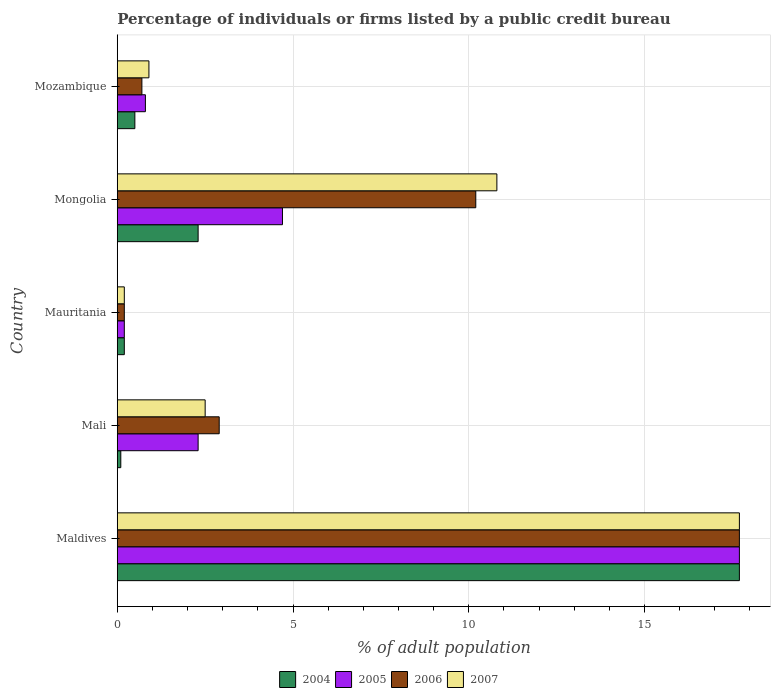How many different coloured bars are there?
Your answer should be compact. 4. How many bars are there on the 1st tick from the bottom?
Provide a short and direct response. 4. What is the label of the 4th group of bars from the top?
Provide a short and direct response. Mali. What is the percentage of population listed by a public credit bureau in 2005 in Maldives?
Give a very brief answer. 17.7. Across all countries, what is the minimum percentage of population listed by a public credit bureau in 2004?
Your response must be concise. 0.1. In which country was the percentage of population listed by a public credit bureau in 2007 maximum?
Offer a very short reply. Maldives. In which country was the percentage of population listed by a public credit bureau in 2007 minimum?
Your response must be concise. Mauritania. What is the total percentage of population listed by a public credit bureau in 2005 in the graph?
Your answer should be compact. 25.7. What is the difference between the percentage of population listed by a public credit bureau in 2007 in Mozambique and the percentage of population listed by a public credit bureau in 2005 in Mongolia?
Keep it short and to the point. -3.8. What is the average percentage of population listed by a public credit bureau in 2007 per country?
Your response must be concise. 6.42. What is the difference between the percentage of population listed by a public credit bureau in 2005 and percentage of population listed by a public credit bureau in 2006 in Mozambique?
Your answer should be compact. 0.1. What is the ratio of the percentage of population listed by a public credit bureau in 2006 in Maldives to that in Mozambique?
Provide a succinct answer. 25.29. Is the percentage of population listed by a public credit bureau in 2006 in Maldives less than that in Mongolia?
Provide a short and direct response. No. Is the difference between the percentage of population listed by a public credit bureau in 2005 in Mali and Mauritania greater than the difference between the percentage of population listed by a public credit bureau in 2006 in Mali and Mauritania?
Make the answer very short. No. What is the difference between the highest and the lowest percentage of population listed by a public credit bureau in 2007?
Give a very brief answer. 17.5. Is the sum of the percentage of population listed by a public credit bureau in 2006 in Mali and Mongolia greater than the maximum percentage of population listed by a public credit bureau in 2005 across all countries?
Provide a succinct answer. No. What does the 4th bar from the bottom in Mauritania represents?
Your answer should be very brief. 2007. Is it the case that in every country, the sum of the percentage of population listed by a public credit bureau in 2005 and percentage of population listed by a public credit bureau in 2006 is greater than the percentage of population listed by a public credit bureau in 2007?
Your answer should be compact. Yes. Are all the bars in the graph horizontal?
Provide a short and direct response. Yes. How many countries are there in the graph?
Provide a short and direct response. 5. What is the difference between two consecutive major ticks on the X-axis?
Keep it short and to the point. 5. Are the values on the major ticks of X-axis written in scientific E-notation?
Offer a very short reply. No. Does the graph contain grids?
Your answer should be very brief. Yes. How many legend labels are there?
Keep it short and to the point. 4. How are the legend labels stacked?
Your response must be concise. Horizontal. What is the title of the graph?
Your response must be concise. Percentage of individuals or firms listed by a public credit bureau. What is the label or title of the X-axis?
Keep it short and to the point. % of adult population. What is the % of adult population of 2004 in Maldives?
Provide a short and direct response. 17.7. What is the % of adult population in 2005 in Maldives?
Ensure brevity in your answer.  17.7. What is the % of adult population in 2006 in Maldives?
Make the answer very short. 17.7. What is the % of adult population in 2004 in Mali?
Your answer should be compact. 0.1. What is the % of adult population of 2005 in Mali?
Your answer should be compact. 2.3. What is the % of adult population in 2006 in Mali?
Your response must be concise. 2.9. What is the % of adult population of 2004 in Mauritania?
Offer a very short reply. 0.2. What is the % of adult population of 2006 in Mongolia?
Your answer should be very brief. 10.2. What is the % of adult population in 2007 in Mongolia?
Your answer should be very brief. 10.8. What is the % of adult population in 2005 in Mozambique?
Provide a short and direct response. 0.8. Across all countries, what is the minimum % of adult population of 2006?
Your answer should be very brief. 0.2. What is the total % of adult population of 2004 in the graph?
Offer a very short reply. 20.8. What is the total % of adult population of 2005 in the graph?
Give a very brief answer. 25.7. What is the total % of adult population in 2006 in the graph?
Provide a succinct answer. 31.7. What is the total % of adult population in 2007 in the graph?
Your response must be concise. 32.1. What is the difference between the % of adult population in 2004 in Maldives and that in Mali?
Your response must be concise. 17.6. What is the difference between the % of adult population of 2005 in Maldives and that in Mali?
Your response must be concise. 15.4. What is the difference between the % of adult population in 2006 in Maldives and that in Mali?
Offer a terse response. 14.8. What is the difference between the % of adult population of 2007 in Maldives and that in Mali?
Your answer should be very brief. 15.2. What is the difference between the % of adult population in 2005 in Maldives and that in Mauritania?
Make the answer very short. 17.5. What is the difference between the % of adult population of 2006 in Maldives and that in Mauritania?
Provide a succinct answer. 17.5. What is the difference between the % of adult population in 2005 in Maldives and that in Mongolia?
Make the answer very short. 13. What is the difference between the % of adult population of 2006 in Mali and that in Mauritania?
Provide a short and direct response. 2.7. What is the difference between the % of adult population in 2005 in Mali and that in Mongolia?
Your response must be concise. -2.4. What is the difference between the % of adult population in 2006 in Mali and that in Mongolia?
Keep it short and to the point. -7.3. What is the difference between the % of adult population in 2004 in Mali and that in Mozambique?
Ensure brevity in your answer.  -0.4. What is the difference between the % of adult population of 2005 in Mali and that in Mozambique?
Your answer should be very brief. 1.5. What is the difference between the % of adult population of 2007 in Mali and that in Mozambique?
Your answer should be compact. 1.6. What is the difference between the % of adult population of 2006 in Mauritania and that in Mongolia?
Keep it short and to the point. -10. What is the difference between the % of adult population in 2005 in Mauritania and that in Mozambique?
Provide a short and direct response. -0.6. What is the difference between the % of adult population in 2007 in Mauritania and that in Mozambique?
Your answer should be compact. -0.7. What is the difference between the % of adult population in 2004 in Mongolia and that in Mozambique?
Provide a succinct answer. 1.8. What is the difference between the % of adult population of 2007 in Mongolia and that in Mozambique?
Provide a succinct answer. 9.9. What is the difference between the % of adult population in 2004 in Maldives and the % of adult population in 2005 in Mali?
Offer a terse response. 15.4. What is the difference between the % of adult population in 2004 in Maldives and the % of adult population in 2007 in Mali?
Your answer should be very brief. 15.2. What is the difference between the % of adult population in 2004 in Maldives and the % of adult population in 2006 in Mauritania?
Your answer should be very brief. 17.5. What is the difference between the % of adult population in 2005 in Maldives and the % of adult population in 2007 in Mauritania?
Ensure brevity in your answer.  17.5. What is the difference between the % of adult population in 2006 in Maldives and the % of adult population in 2007 in Mauritania?
Ensure brevity in your answer.  17.5. What is the difference between the % of adult population of 2004 in Maldives and the % of adult population of 2005 in Mongolia?
Ensure brevity in your answer.  13. What is the difference between the % of adult population of 2004 in Maldives and the % of adult population of 2007 in Mongolia?
Offer a terse response. 6.9. What is the difference between the % of adult population of 2005 in Maldives and the % of adult population of 2006 in Mongolia?
Make the answer very short. 7.5. What is the difference between the % of adult population in 2006 in Maldives and the % of adult population in 2007 in Mongolia?
Ensure brevity in your answer.  6.9. What is the difference between the % of adult population of 2004 in Maldives and the % of adult population of 2006 in Mozambique?
Provide a succinct answer. 17. What is the difference between the % of adult population of 2005 in Maldives and the % of adult population of 2007 in Mozambique?
Offer a terse response. 16.8. What is the difference between the % of adult population in 2006 in Maldives and the % of adult population in 2007 in Mozambique?
Keep it short and to the point. 16.8. What is the difference between the % of adult population in 2004 in Mali and the % of adult population in 2005 in Mauritania?
Your answer should be very brief. -0.1. What is the difference between the % of adult population in 2005 in Mali and the % of adult population in 2006 in Mauritania?
Provide a short and direct response. 2.1. What is the difference between the % of adult population of 2006 in Mali and the % of adult population of 2007 in Mauritania?
Offer a very short reply. 2.7. What is the difference between the % of adult population of 2004 in Mali and the % of adult population of 2005 in Mongolia?
Offer a terse response. -4.6. What is the difference between the % of adult population of 2004 in Mali and the % of adult population of 2007 in Mongolia?
Your answer should be compact. -10.7. What is the difference between the % of adult population of 2004 in Mali and the % of adult population of 2007 in Mozambique?
Your response must be concise. -0.8. What is the difference between the % of adult population of 2005 in Mali and the % of adult population of 2006 in Mozambique?
Your response must be concise. 1.6. What is the difference between the % of adult population in 2005 in Mali and the % of adult population in 2007 in Mozambique?
Your answer should be compact. 1.4. What is the difference between the % of adult population in 2006 in Mali and the % of adult population in 2007 in Mozambique?
Your answer should be compact. 2. What is the difference between the % of adult population of 2004 in Mauritania and the % of adult population of 2005 in Mongolia?
Make the answer very short. -4.5. What is the difference between the % of adult population of 2004 in Mauritania and the % of adult population of 2006 in Mongolia?
Offer a terse response. -10. What is the difference between the % of adult population in 2004 in Mauritania and the % of adult population in 2007 in Mongolia?
Provide a short and direct response. -10.6. What is the difference between the % of adult population in 2005 in Mauritania and the % of adult population in 2006 in Mongolia?
Your answer should be very brief. -10. What is the difference between the % of adult population of 2005 in Mauritania and the % of adult population of 2007 in Mongolia?
Keep it short and to the point. -10.6. What is the difference between the % of adult population in 2004 in Mauritania and the % of adult population in 2007 in Mozambique?
Your answer should be compact. -0.7. What is the difference between the % of adult population of 2005 in Mauritania and the % of adult population of 2006 in Mozambique?
Make the answer very short. -0.5. What is the difference between the % of adult population of 2005 in Mauritania and the % of adult population of 2007 in Mozambique?
Your answer should be compact. -0.7. What is the difference between the % of adult population in 2004 in Mongolia and the % of adult population in 2005 in Mozambique?
Your answer should be very brief. 1.5. What is the difference between the % of adult population of 2005 in Mongolia and the % of adult population of 2006 in Mozambique?
Provide a succinct answer. 4. What is the difference between the % of adult population in 2006 in Mongolia and the % of adult population in 2007 in Mozambique?
Provide a succinct answer. 9.3. What is the average % of adult population in 2004 per country?
Provide a short and direct response. 4.16. What is the average % of adult population of 2005 per country?
Your answer should be compact. 5.14. What is the average % of adult population of 2006 per country?
Your answer should be compact. 6.34. What is the average % of adult population in 2007 per country?
Your response must be concise. 6.42. What is the difference between the % of adult population in 2004 and % of adult population in 2006 in Maldives?
Your response must be concise. 0. What is the difference between the % of adult population of 2005 and % of adult population of 2007 in Maldives?
Provide a succinct answer. 0. What is the difference between the % of adult population of 2004 and % of adult population of 2005 in Mali?
Keep it short and to the point. -2.2. What is the difference between the % of adult population in 2004 and % of adult population in 2007 in Mali?
Keep it short and to the point. -2.4. What is the difference between the % of adult population in 2006 and % of adult population in 2007 in Mali?
Keep it short and to the point. 0.4. What is the difference between the % of adult population in 2004 and % of adult population in 2007 in Mauritania?
Provide a succinct answer. 0. What is the difference between the % of adult population in 2005 and % of adult population in 2006 in Mauritania?
Make the answer very short. 0. What is the difference between the % of adult population in 2006 and % of adult population in 2007 in Mauritania?
Keep it short and to the point. 0. What is the difference between the % of adult population in 2004 and % of adult population in 2006 in Mongolia?
Your answer should be very brief. -7.9. What is the difference between the % of adult population of 2005 and % of adult population of 2006 in Mongolia?
Your response must be concise. -5.5. What is the difference between the % of adult population in 2006 and % of adult population in 2007 in Mongolia?
Your answer should be compact. -0.6. What is the difference between the % of adult population in 2004 and % of adult population in 2006 in Mozambique?
Offer a terse response. -0.2. What is the difference between the % of adult population of 2005 and % of adult population of 2007 in Mozambique?
Provide a short and direct response. -0.1. What is the difference between the % of adult population of 2006 and % of adult population of 2007 in Mozambique?
Your answer should be compact. -0.2. What is the ratio of the % of adult population of 2004 in Maldives to that in Mali?
Your response must be concise. 177. What is the ratio of the % of adult population of 2005 in Maldives to that in Mali?
Ensure brevity in your answer.  7.7. What is the ratio of the % of adult population of 2006 in Maldives to that in Mali?
Make the answer very short. 6.1. What is the ratio of the % of adult population in 2007 in Maldives to that in Mali?
Ensure brevity in your answer.  7.08. What is the ratio of the % of adult population of 2004 in Maldives to that in Mauritania?
Your answer should be very brief. 88.5. What is the ratio of the % of adult population in 2005 in Maldives to that in Mauritania?
Give a very brief answer. 88.5. What is the ratio of the % of adult population of 2006 in Maldives to that in Mauritania?
Provide a short and direct response. 88.5. What is the ratio of the % of adult population of 2007 in Maldives to that in Mauritania?
Offer a terse response. 88.5. What is the ratio of the % of adult population of 2004 in Maldives to that in Mongolia?
Ensure brevity in your answer.  7.7. What is the ratio of the % of adult population of 2005 in Maldives to that in Mongolia?
Offer a terse response. 3.77. What is the ratio of the % of adult population in 2006 in Maldives to that in Mongolia?
Keep it short and to the point. 1.74. What is the ratio of the % of adult population in 2007 in Maldives to that in Mongolia?
Provide a short and direct response. 1.64. What is the ratio of the % of adult population of 2004 in Maldives to that in Mozambique?
Give a very brief answer. 35.4. What is the ratio of the % of adult population of 2005 in Maldives to that in Mozambique?
Your answer should be very brief. 22.12. What is the ratio of the % of adult population of 2006 in Maldives to that in Mozambique?
Offer a very short reply. 25.29. What is the ratio of the % of adult population in 2007 in Maldives to that in Mozambique?
Your answer should be compact. 19.67. What is the ratio of the % of adult population in 2004 in Mali to that in Mauritania?
Your answer should be very brief. 0.5. What is the ratio of the % of adult population in 2006 in Mali to that in Mauritania?
Make the answer very short. 14.5. What is the ratio of the % of adult population in 2004 in Mali to that in Mongolia?
Give a very brief answer. 0.04. What is the ratio of the % of adult population of 2005 in Mali to that in Mongolia?
Your response must be concise. 0.49. What is the ratio of the % of adult population of 2006 in Mali to that in Mongolia?
Keep it short and to the point. 0.28. What is the ratio of the % of adult population in 2007 in Mali to that in Mongolia?
Offer a very short reply. 0.23. What is the ratio of the % of adult population in 2004 in Mali to that in Mozambique?
Give a very brief answer. 0.2. What is the ratio of the % of adult population of 2005 in Mali to that in Mozambique?
Offer a very short reply. 2.88. What is the ratio of the % of adult population of 2006 in Mali to that in Mozambique?
Make the answer very short. 4.14. What is the ratio of the % of adult population in 2007 in Mali to that in Mozambique?
Your answer should be very brief. 2.78. What is the ratio of the % of adult population of 2004 in Mauritania to that in Mongolia?
Offer a terse response. 0.09. What is the ratio of the % of adult population of 2005 in Mauritania to that in Mongolia?
Keep it short and to the point. 0.04. What is the ratio of the % of adult population in 2006 in Mauritania to that in Mongolia?
Your response must be concise. 0.02. What is the ratio of the % of adult population of 2007 in Mauritania to that in Mongolia?
Offer a very short reply. 0.02. What is the ratio of the % of adult population in 2005 in Mauritania to that in Mozambique?
Provide a succinct answer. 0.25. What is the ratio of the % of adult population in 2006 in Mauritania to that in Mozambique?
Provide a succinct answer. 0.29. What is the ratio of the % of adult population of 2007 in Mauritania to that in Mozambique?
Your answer should be very brief. 0.22. What is the ratio of the % of adult population in 2005 in Mongolia to that in Mozambique?
Give a very brief answer. 5.88. What is the ratio of the % of adult population of 2006 in Mongolia to that in Mozambique?
Provide a short and direct response. 14.57. What is the difference between the highest and the second highest % of adult population in 2005?
Your answer should be compact. 13. What is the difference between the highest and the lowest % of adult population in 2005?
Offer a terse response. 17.5. What is the difference between the highest and the lowest % of adult population in 2006?
Ensure brevity in your answer.  17.5. 